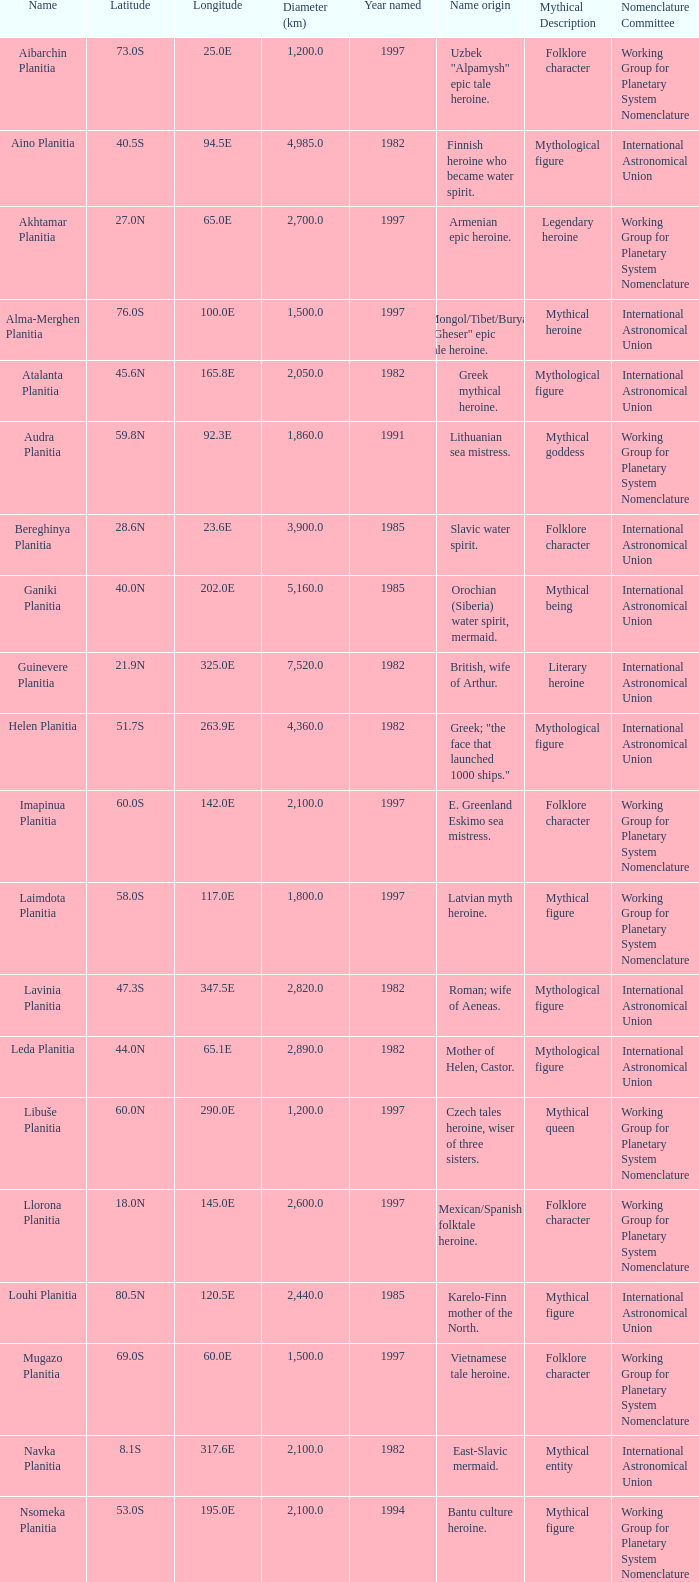What is the diameter (km) of longitude 170.1e 3655.0. 